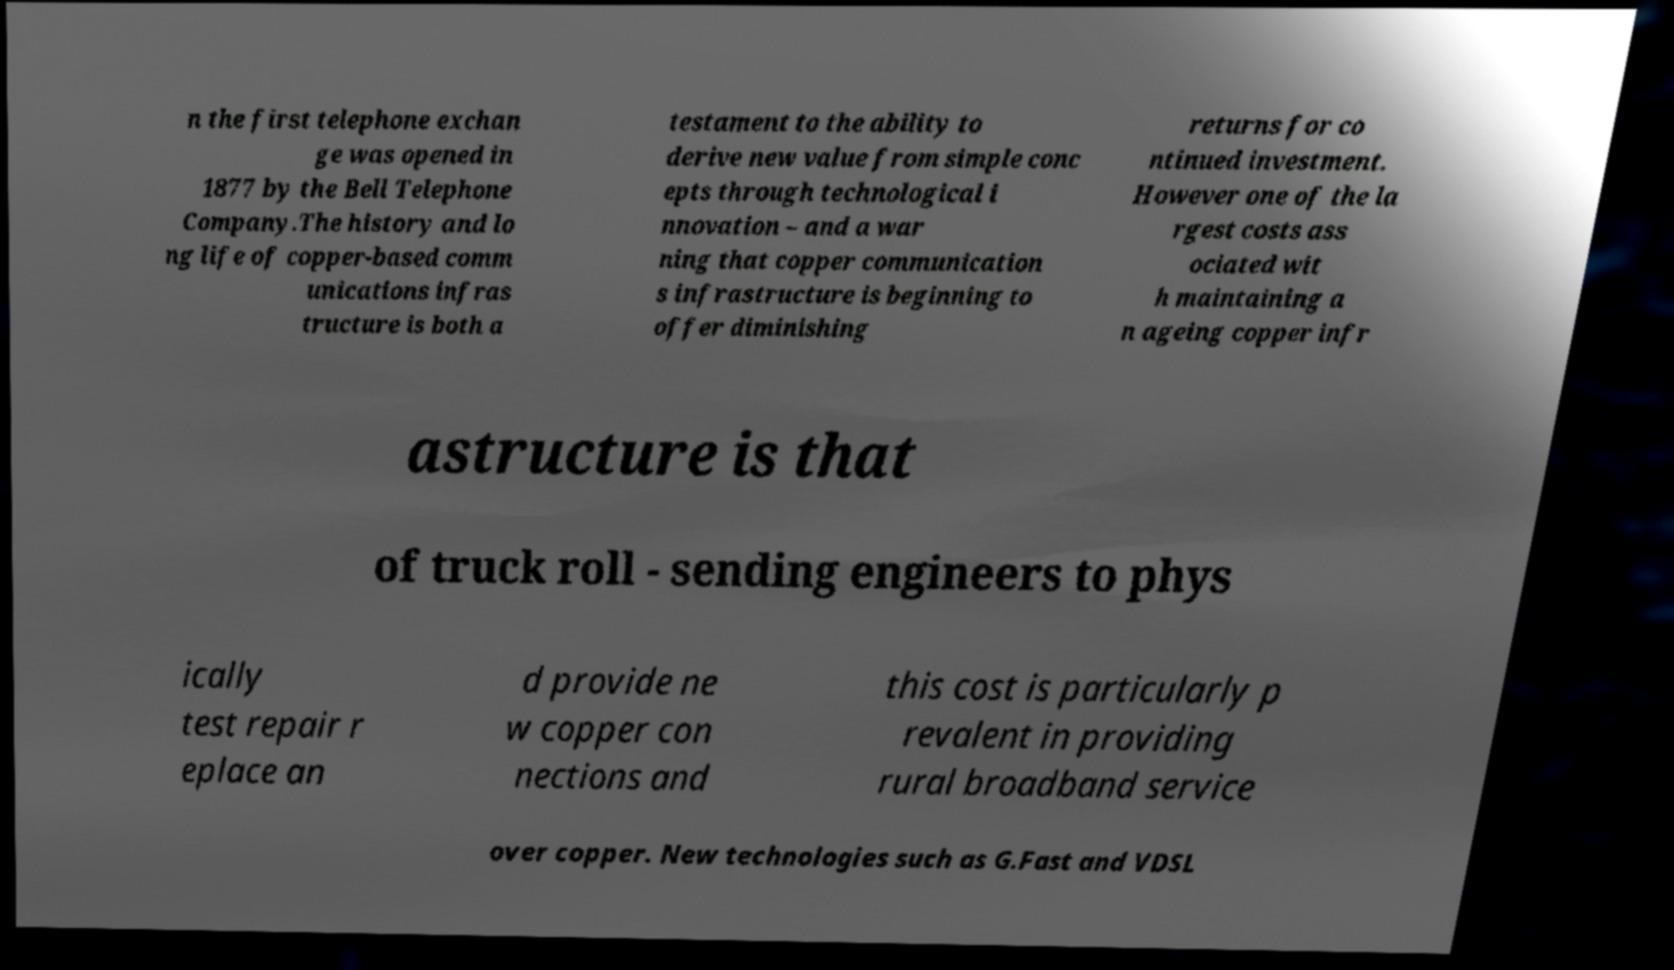Please identify and transcribe the text found in this image. n the first telephone exchan ge was opened in 1877 by the Bell Telephone Company.The history and lo ng life of copper-based comm unications infras tructure is both a testament to the ability to derive new value from simple conc epts through technological i nnovation – and a war ning that copper communication s infrastructure is beginning to offer diminishing returns for co ntinued investment. However one of the la rgest costs ass ociated wit h maintaining a n ageing copper infr astructure is that of truck roll - sending engineers to phys ically test repair r eplace an d provide ne w copper con nections and this cost is particularly p revalent in providing rural broadband service over copper. New technologies such as G.Fast and VDSL 